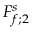Convert formula to latex. <formula><loc_0><loc_0><loc_500><loc_500>F _ { f ; 2 } ^ { s }</formula> 